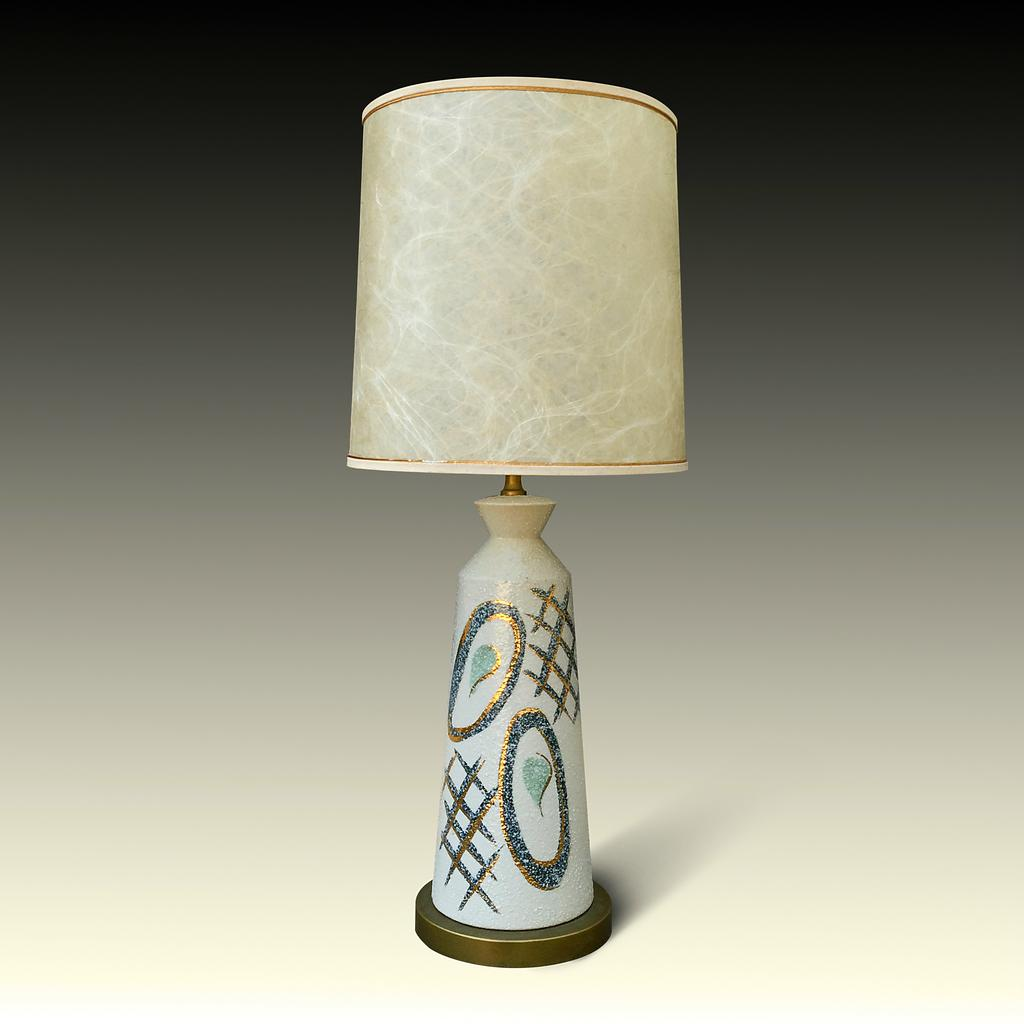What is the main object in the image? There is a lamp in the image. Can you describe the lamp's location? The lamp is on an object. How many eggs are present on the lamp in the image? There are no eggs present on the lamp in the image. What level of education does the lamp have in the image? The lamp is an inanimate object and does not have a level of education. 